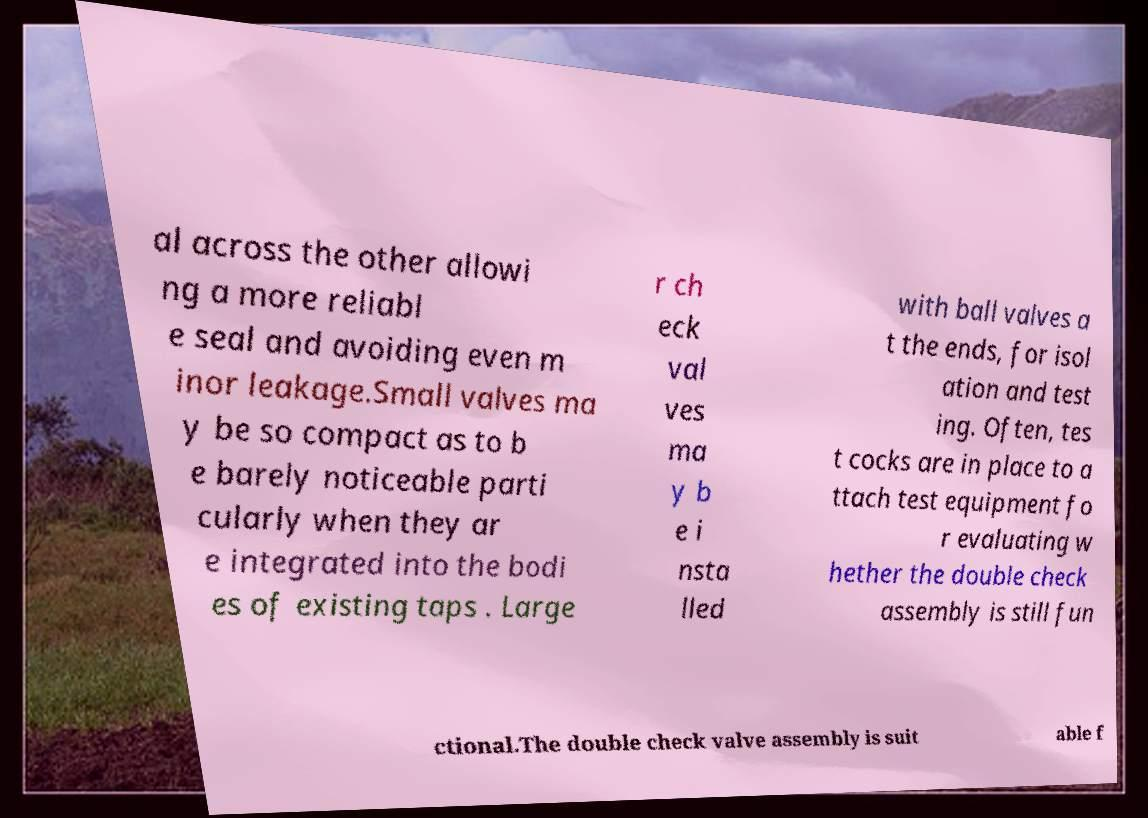Please read and relay the text visible in this image. What does it say? al across the other allowi ng a more reliabl e seal and avoiding even m inor leakage.Small valves ma y be so compact as to b e barely noticeable parti cularly when they ar e integrated into the bodi es of existing taps . Large r ch eck val ves ma y b e i nsta lled with ball valves a t the ends, for isol ation and test ing. Often, tes t cocks are in place to a ttach test equipment fo r evaluating w hether the double check assembly is still fun ctional.The double check valve assembly is suit able f 